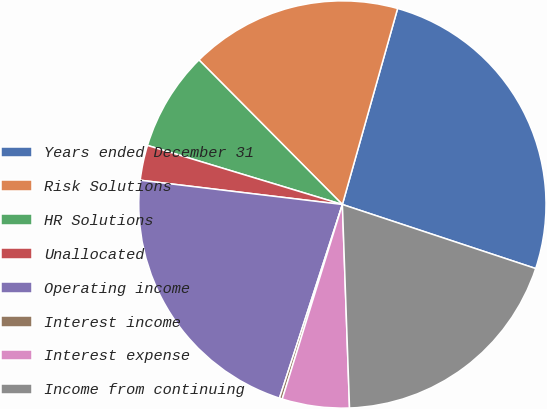Convert chart to OTSL. <chart><loc_0><loc_0><loc_500><loc_500><pie_chart><fcel>Years ended December 31<fcel>Risk Solutions<fcel>HR Solutions<fcel>Unallocated<fcel>Operating income<fcel>Interest income<fcel>Interest expense<fcel>Income from continuing<nl><fcel>25.72%<fcel>16.81%<fcel>7.88%<fcel>2.78%<fcel>21.9%<fcel>0.23%<fcel>5.33%<fcel>19.35%<nl></chart> 